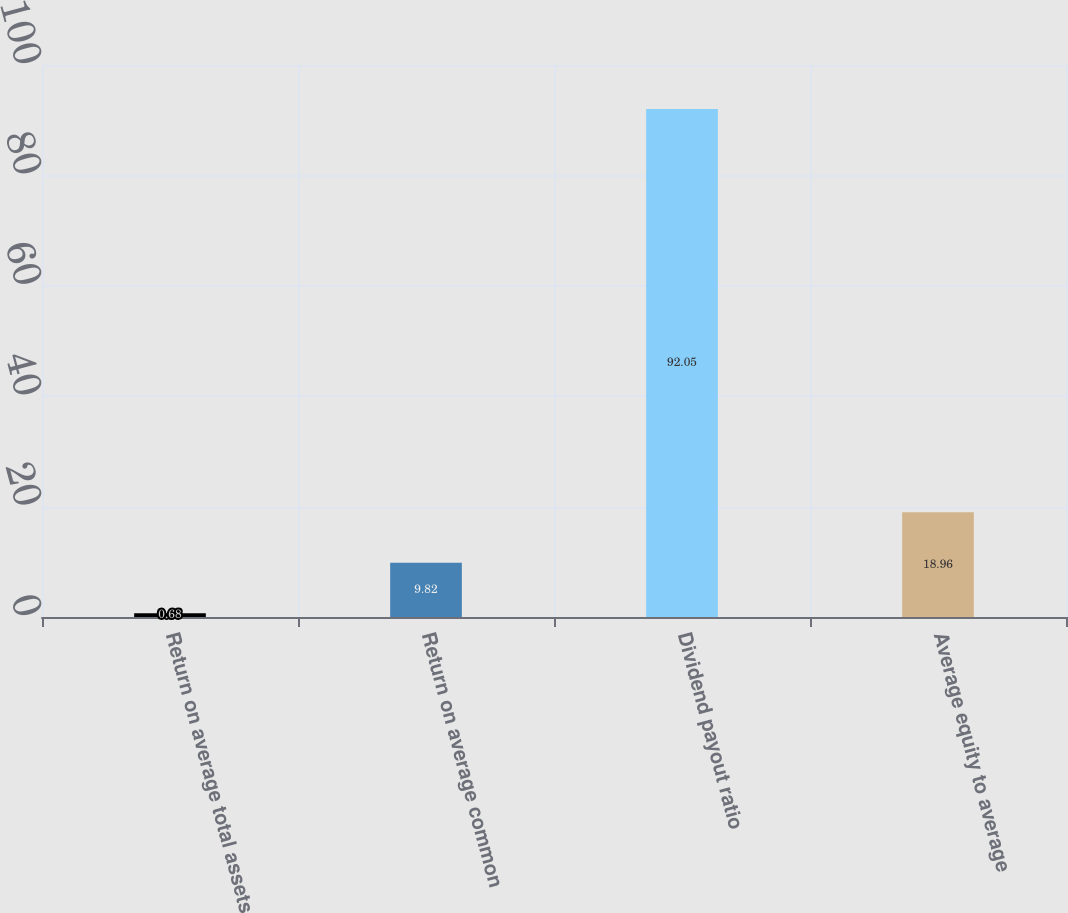Convert chart to OTSL. <chart><loc_0><loc_0><loc_500><loc_500><bar_chart><fcel>Return on average total assets<fcel>Return on average common<fcel>Dividend payout ratio<fcel>Average equity to average<nl><fcel>0.68<fcel>9.82<fcel>92.05<fcel>18.96<nl></chart> 